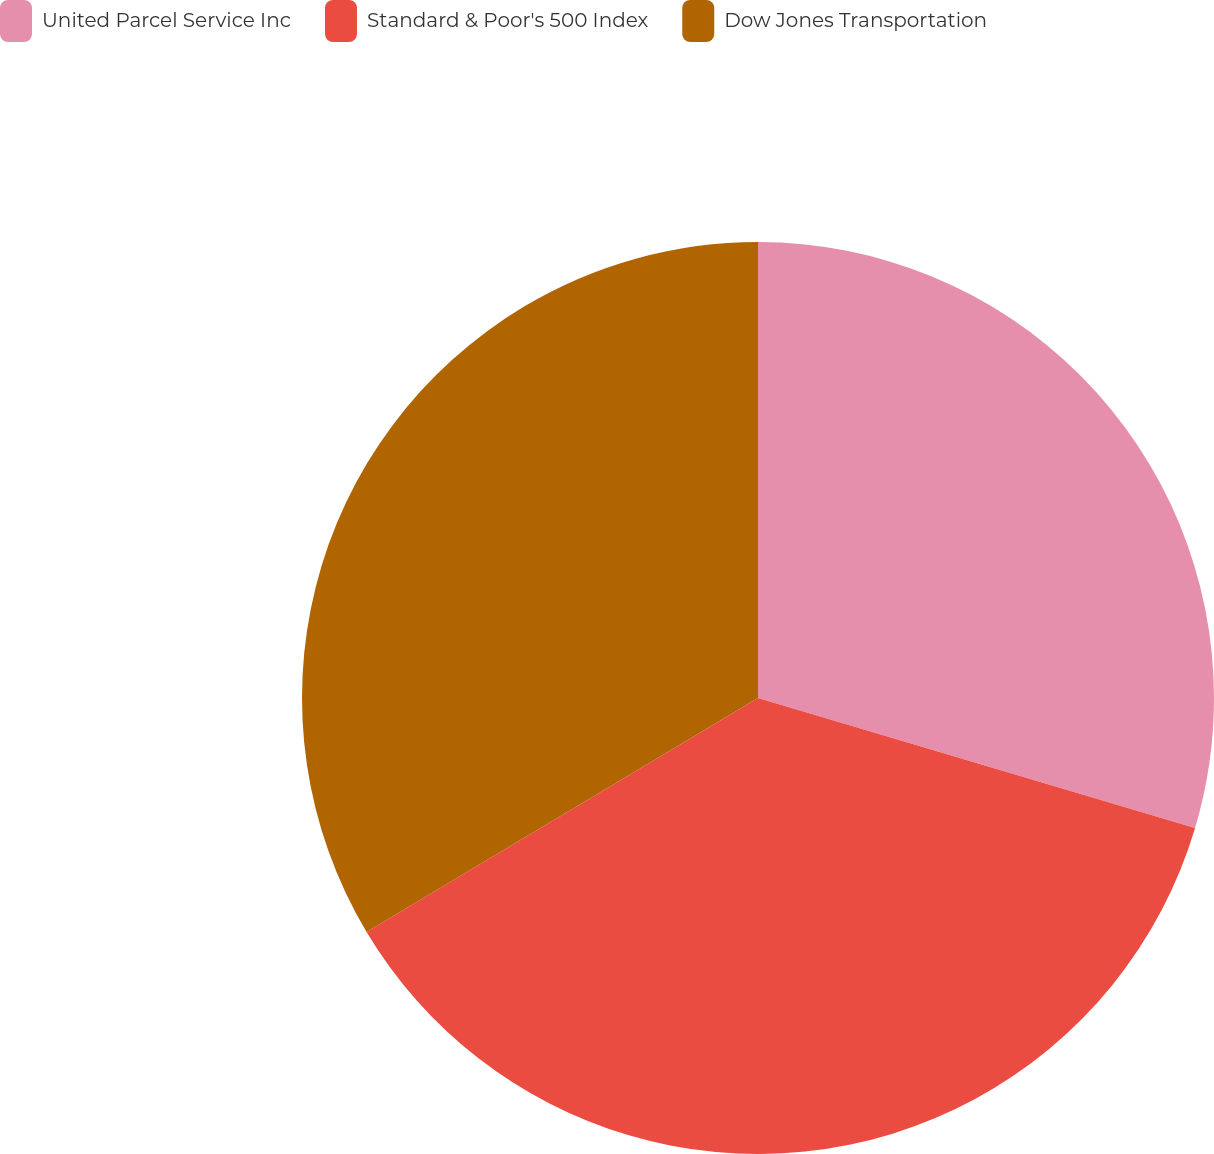Convert chart to OTSL. <chart><loc_0><loc_0><loc_500><loc_500><pie_chart><fcel>United Parcel Service Inc<fcel>Standard & Poor's 500 Index<fcel>Dow Jones Transportation<nl><fcel>29.6%<fcel>36.82%<fcel>33.57%<nl></chart> 